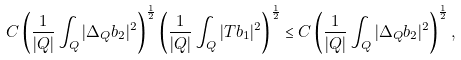Convert formula to latex. <formula><loc_0><loc_0><loc_500><loc_500>C \left ( \frac { 1 } { | Q | } \int _ { Q } | \Delta _ { Q } b _ { 2 } | ^ { 2 } \right ) ^ { \frac { 1 } { 2 } } \left ( \frac { 1 } { | Q | } \int _ { Q } | T b _ { 1 } | ^ { 2 } \right ) ^ { \frac { 1 } { 2 } } \leq C \left ( \frac { 1 } { | Q | } \int _ { Q } | \Delta _ { Q } b _ { 2 } | ^ { 2 } \right ) ^ { \frac { 1 } { 2 } } ,</formula> 